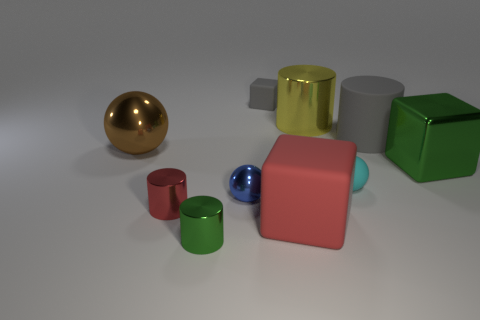What material is the big green thing that is the same shape as the tiny gray rubber object?
Ensure brevity in your answer.  Metal. There is a shiny cylinder behind the metal block; is it the same size as the rubber cylinder?
Your response must be concise. Yes. There is a tiny matte ball; what number of yellow objects are right of it?
Your response must be concise. 0. Are there fewer blue objects that are left of the tiny green thing than small spheres that are in front of the yellow metallic cylinder?
Provide a succinct answer. Yes. What number of big purple spheres are there?
Give a very brief answer. 0. There is a cube on the right side of the big gray object; what is its color?
Provide a succinct answer. Green. What size is the cyan rubber thing?
Provide a succinct answer. Small. Is the color of the tiny cube the same as the large rubber thing that is behind the tiny red shiny thing?
Your answer should be compact. Yes. There is a small metallic cylinder that is left of the object that is in front of the large rubber cube; what color is it?
Your answer should be compact. Red. There is a green metallic thing that is behind the big red rubber object; does it have the same shape as the red rubber thing?
Your response must be concise. Yes. 